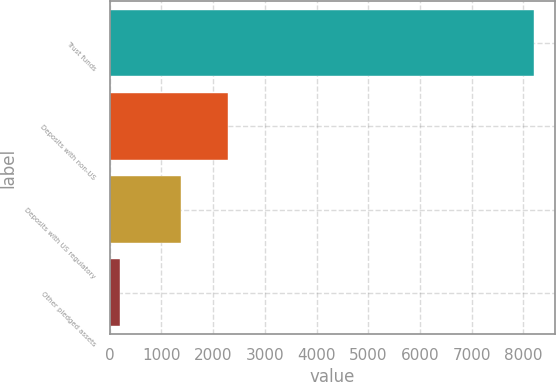Convert chart. <chart><loc_0><loc_0><loc_500><loc_500><bar_chart><fcel>Trust funds<fcel>Deposits with non-US<fcel>Deposits with US regulatory<fcel>Other pledged assets<nl><fcel>8200<fcel>2289<fcel>1384<fcel>190<nl></chart> 